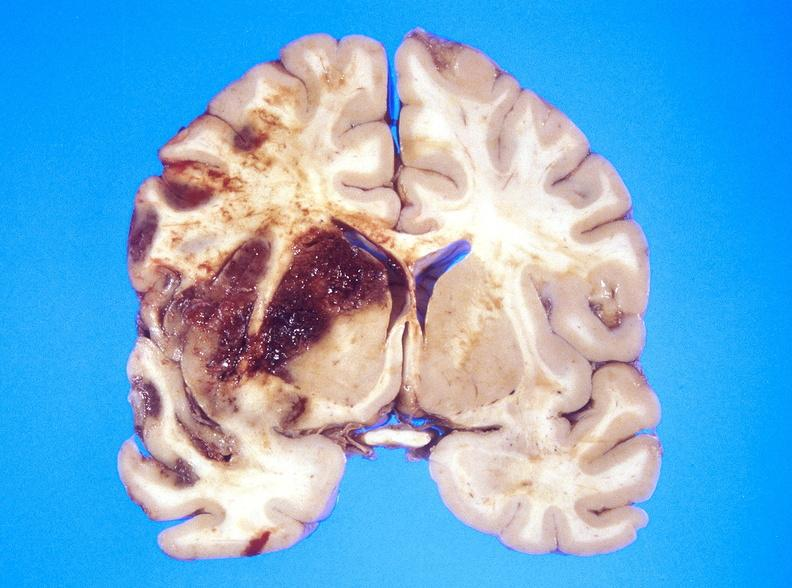what does this image show?
Answer the question using a single word or phrase. Hemorrhagic reperfusion infarct 